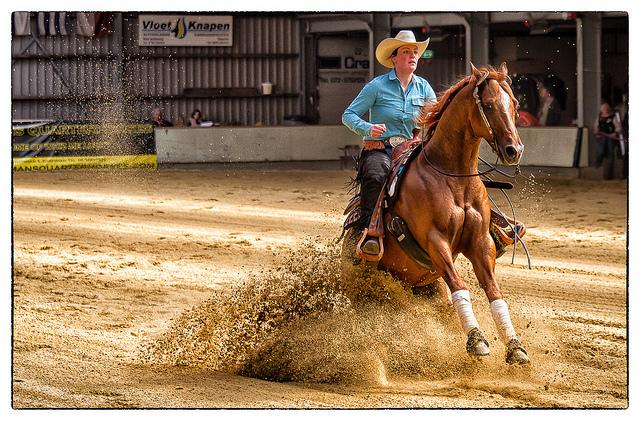Why is the horse on the the ground?

Choices:
A) resting
B) getting even
C) fell
D) backing up fell 